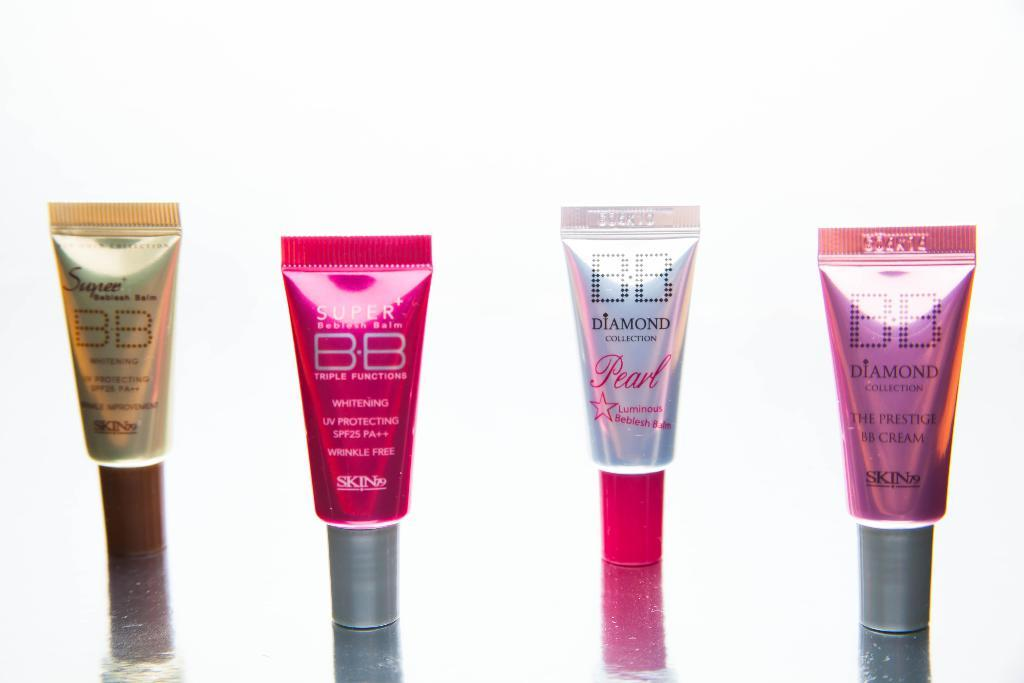Provide a one-sentence caption for the provided image. Four small tubes of BB brand cream with two labeled super and the other two labeled diamond collection. 